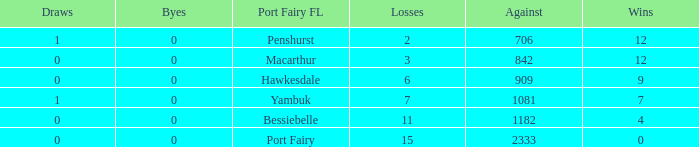How many wins for Port Fairy and against more than 2333? None. 